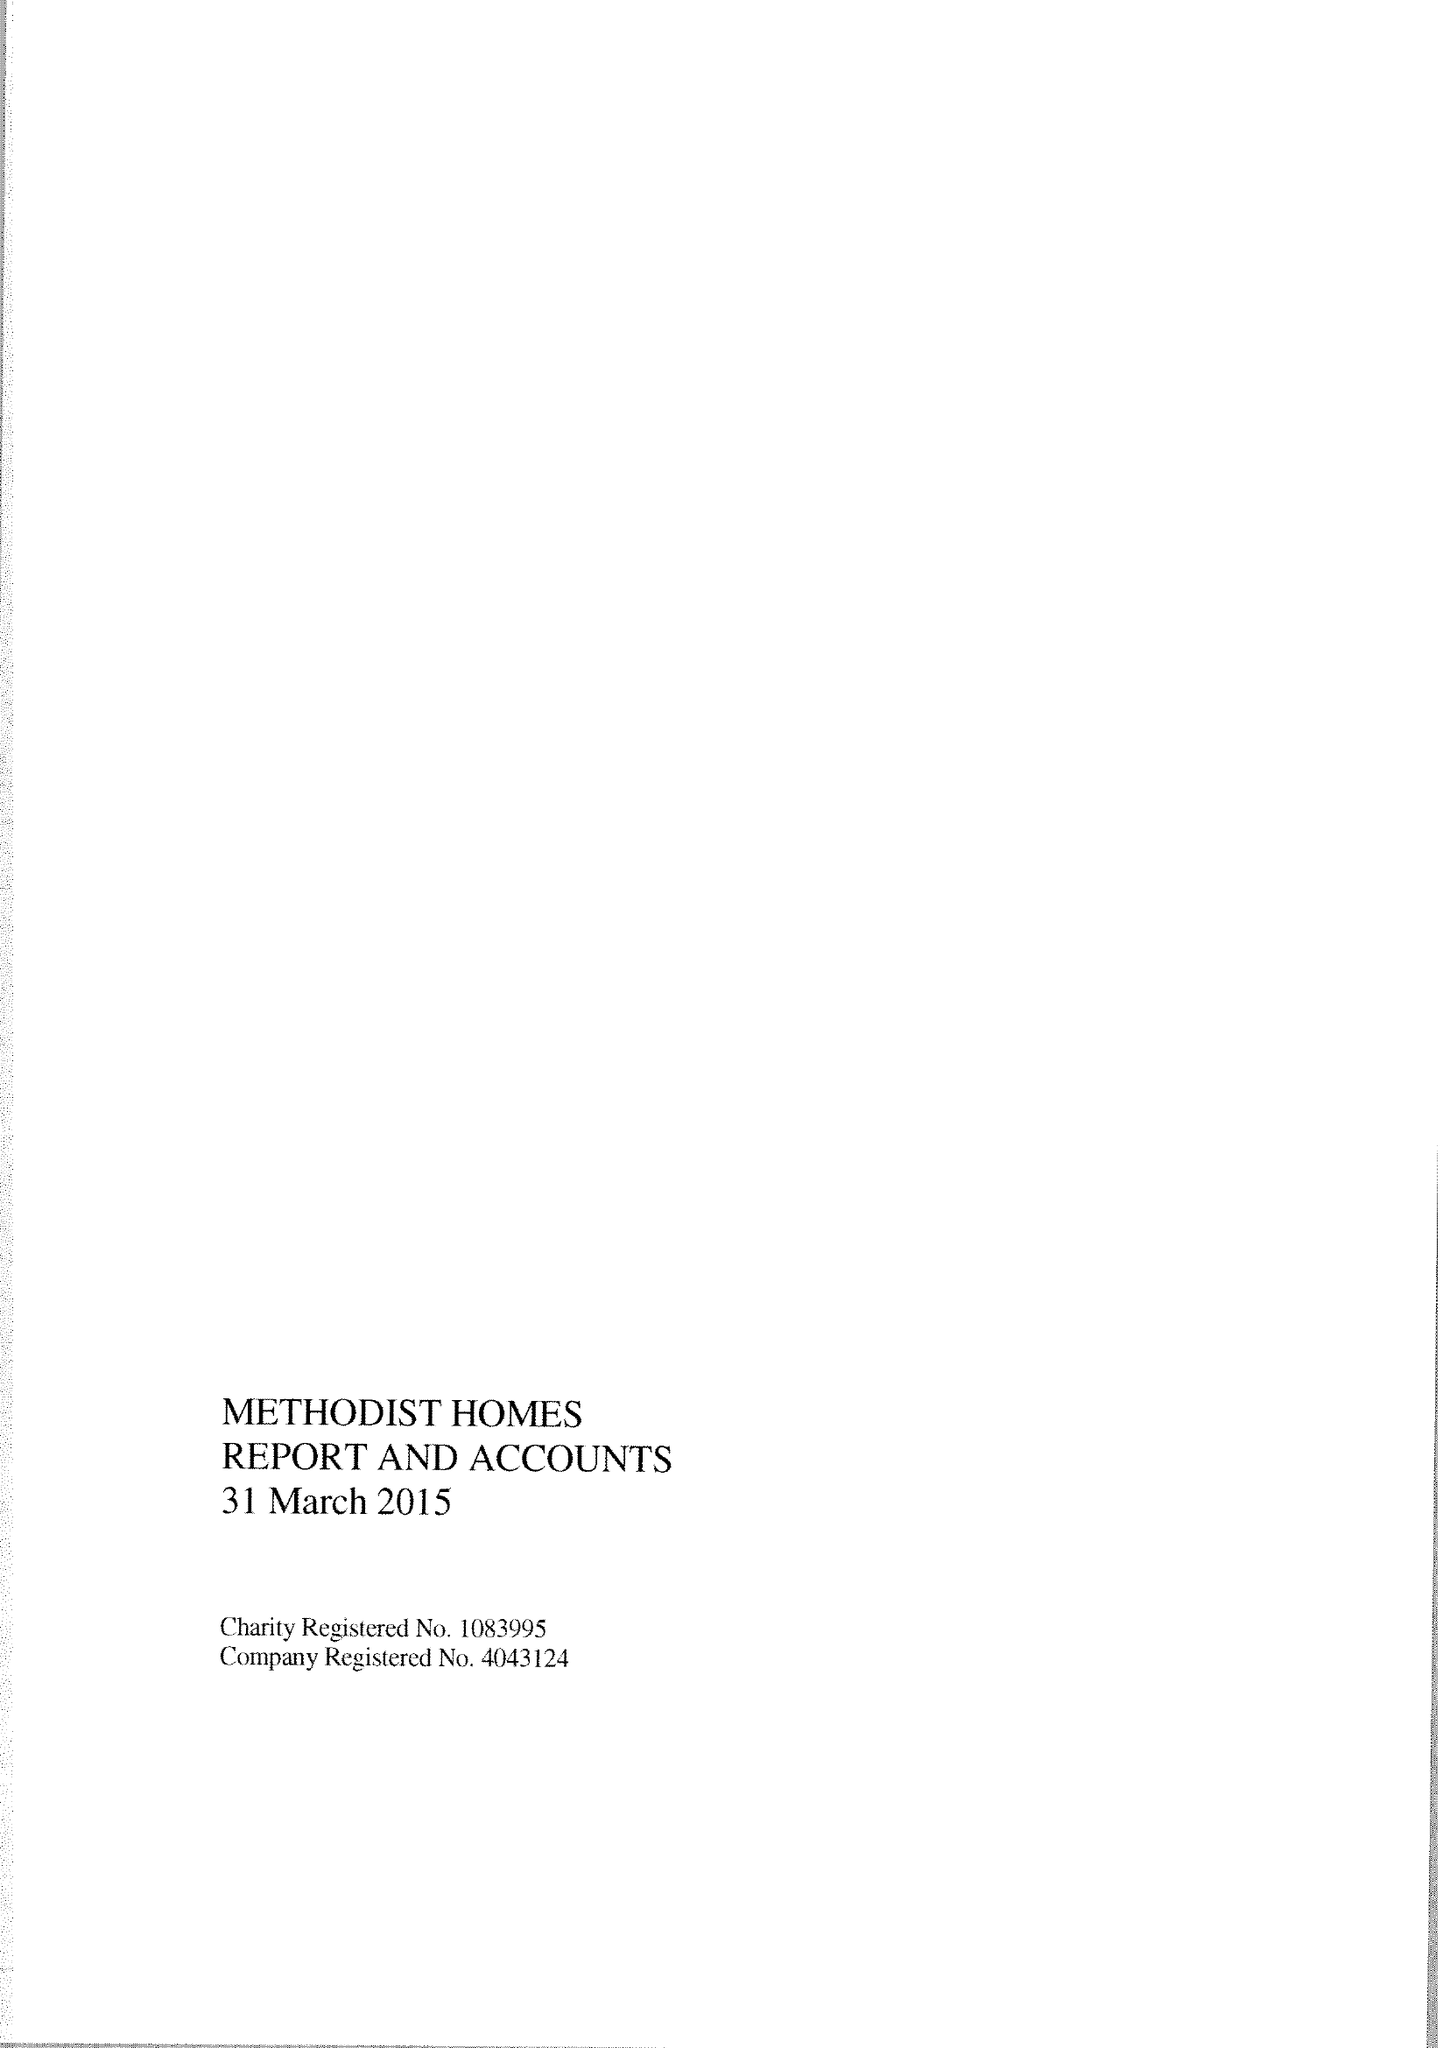What is the value for the address__street_line?
Answer the question using a single word or phrase. STUART STREET 